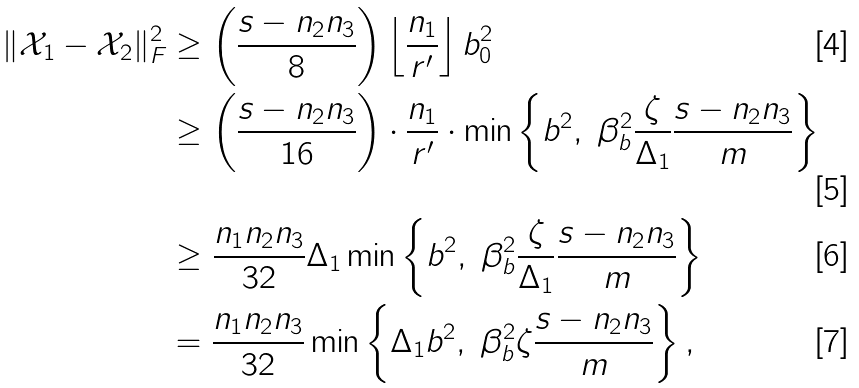Convert formula to latex. <formula><loc_0><loc_0><loc_500><loc_500>\| \mathcal { X } _ { 1 } - \mathcal { X } _ { 2 } \| _ { F } ^ { 2 } & \geq \left ( \frac { s - n _ { 2 } n _ { 3 } } { 8 } \right ) \left \lfloor \frac { n _ { 1 } } { r ^ { \prime } } \right \rfloor b _ { 0 } ^ { 2 } \\ & \geq \left ( \frac { s - n _ { 2 } n _ { 3 } } { 1 6 } \right ) \cdot \frac { n _ { 1 } } { r ^ { \prime } } \cdot \min \left \{ b ^ { 2 } , \ \beta _ { b } ^ { 2 } \frac { \zeta } { \Delta _ { 1 } } \frac { s - n _ { 2 } n _ { 3 } } { m } \right \} \\ & \geq \frac { n _ { 1 } n _ { 2 } n _ { 3 } } { 3 2 } \Delta _ { 1 } \min \left \{ b ^ { 2 } , \ \beta _ { b } ^ { 2 } \frac { \zeta } { \Delta _ { 1 } } \frac { s - n _ { 2 } n _ { 3 } } { m } \right \} \\ & = \frac { n _ { 1 } n _ { 2 } n _ { 3 } } { 3 2 } \min \left \{ \Delta _ { 1 } b ^ { 2 } , \ \beta _ { b } ^ { 2 } \zeta \frac { s - n _ { 2 } n _ { 3 } } { m } \right \} ,</formula> 